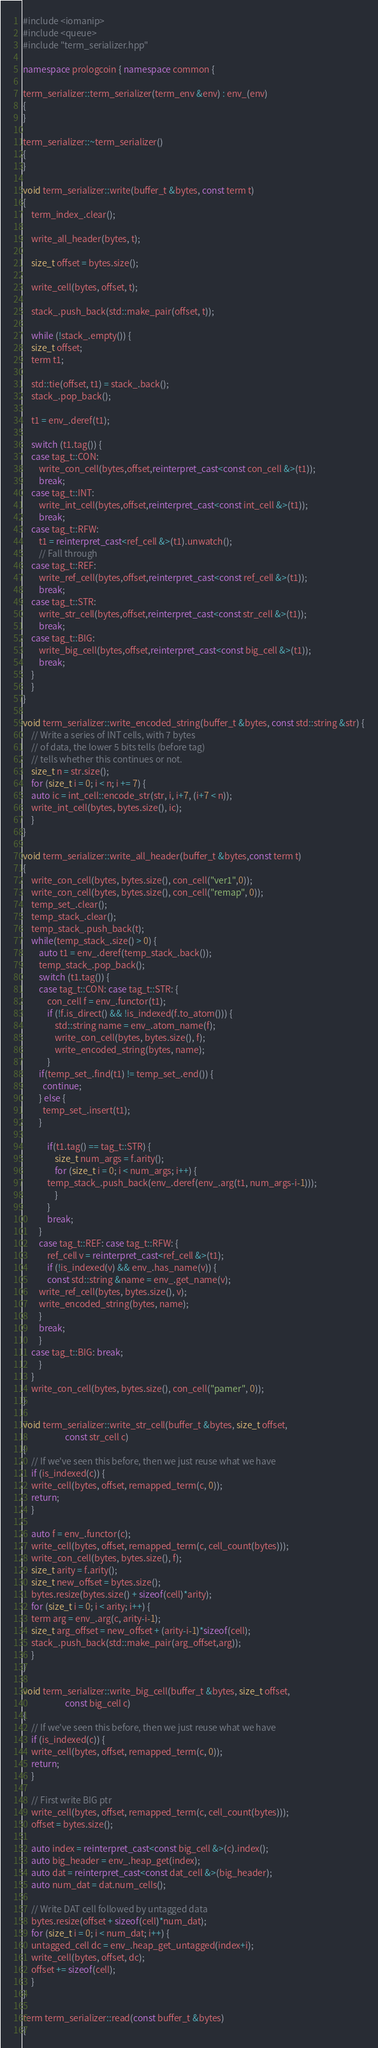Convert code to text. <code><loc_0><loc_0><loc_500><loc_500><_C++_>#include <iomanip>
#include <queue>
#include "term_serializer.hpp"

namespace prologcoin { namespace common {

term_serializer::term_serializer(term_env &env) : env_(env)
{
}

term_serializer::~term_serializer()
{
}

void term_serializer::write(buffer_t &bytes, const term t)
{
    term_index_.clear();
    
    write_all_header(bytes, t);

    size_t offset = bytes.size();

    write_cell(bytes, offset, t);

    stack_.push_back(std::make_pair(offset, t));

    while (!stack_.empty()) {
	size_t offset;
	term t1;

	std::tie(offset, t1) = stack_.back();
	stack_.pop_back();

	t1 = env_.deref(t1);

	switch (t1.tag()) {
	case tag_t::CON:
	    write_con_cell(bytes,offset,reinterpret_cast<const con_cell &>(t1));
	    break;
	case tag_t::INT:
	    write_int_cell(bytes,offset,reinterpret_cast<const int_cell &>(t1));
	    break;
	case tag_t::RFW:
	    t1 = reinterpret_cast<ref_cell &>(t1).unwatch();
	    // Fall through
	case tag_t::REF:
	    write_ref_cell(bytes,offset,reinterpret_cast<const ref_cell &>(t1));
	    break;
	case tag_t::STR:
	    write_str_cell(bytes,offset,reinterpret_cast<const str_cell &>(t1));
	    break;
	case tag_t::BIG:
	    write_big_cell(bytes,offset,reinterpret_cast<const big_cell &>(t1));
	    break;
	}
    }
}

void term_serializer::write_encoded_string(buffer_t &bytes, const std::string &str) {
    // Write a series of INT cells, with 7 bytes
    // of data, the lower 5 bits tells (before tag)
    // tells whether this continues or not.
    size_t n = str.size();
    for (size_t i = 0; i < n; i += 7) {
	auto ic = int_cell::encode_str(str, i, i+7, (i+7 < n));
	write_int_cell(bytes, bytes.size(), ic);
    }
}

void term_serializer::write_all_header(buffer_t &bytes,const term t)
{
    write_con_cell(bytes, bytes.size(), con_cell("ver1",0));
    write_con_cell(bytes, bytes.size(), con_cell("remap", 0));
    temp_set_.clear();
    temp_stack_.clear();
    temp_stack_.push_back(t);
    while(temp_stack_.size() > 0) {
        auto t1 = env_.deref(temp_stack_.back());
        temp_stack_.pop_back();
        switch (t1.tag()) {
        case tag_t::CON: case tag_t::STR: {
            con_cell f = env_.functor(t1);
            if (!f.is_direct() && !is_indexed(f.to_atom())) {
                std::string name = env_.atom_name(f);
                write_con_cell(bytes, bytes.size(), f);
                write_encoded_string(bytes, name);
            }
	    if(temp_set_.find(t1) != temp_set_.end()) {
	      continue;
	    } else {
	      temp_set_.insert(t1);
	    }

            if(t1.tag() == tag_t::STR) {
                size_t num_args = f.arity();
                for (size_t i = 0; i < num_args; i++) {
		    temp_stack_.push_back(env_.deref(env_.arg(t1, num_args-i-1)));
                }
            }
            break;
        }
        case tag_t::REF: case tag_t::RFW: { 
            ref_cell v = reinterpret_cast<ref_cell &>(t1);
            if (!is_indexed(v) && env_.has_name(v)) {
	        const std::string &name = env_.get_name(v);
		write_ref_cell(bytes, bytes.size(), v);
		write_encoded_string(bytes, name);
	    }
	    break;
	    }
	case tag_t::BIG: break;
        }
    }
    write_con_cell(bytes, bytes.size(), con_cell("pamer", 0));
}

void term_serializer::write_str_cell(buffer_t &bytes, size_t offset,
				     const str_cell c)
{
    // If we've seen this before, then we just reuse what we have
    if (is_indexed(c)) {
	write_cell(bytes, offset, remapped_term(c, 0));
	return;
    }

    auto f = env_.functor(c);
    write_cell(bytes, offset, remapped_term(c, cell_count(bytes)));
    write_con_cell(bytes, bytes.size(), f);
    size_t arity = f.arity();
    size_t new_offset = bytes.size();
    bytes.resize(bytes.size() + sizeof(cell)*arity);
    for (size_t i = 0; i < arity; i++) {
	term arg = env_.arg(c, arity-i-1);
	size_t arg_offset = new_offset + (arity-i-1)*sizeof(cell);
	stack_.push_back(std::make_pair(arg_offset,arg));
    }
}

void term_serializer::write_big_cell(buffer_t &bytes, size_t offset,
				     const big_cell c)
{
    // If we've seen this before, then we just reuse what we have
    if (is_indexed(c)) {
	write_cell(bytes, offset, remapped_term(c, 0));
	return;
    }

    // First write BIG ptr
    write_cell(bytes, offset, remapped_term(c, cell_count(bytes)));
    offset = bytes.size();

    auto index = reinterpret_cast<const big_cell &>(c).index();
    auto big_header = env_.heap_get(index);
    auto dat = reinterpret_cast<const dat_cell &>(big_header);
    auto num_dat = dat.num_cells();

    // Write DAT cell followed by untagged data
    bytes.resize(offset + sizeof(cell)*num_dat);
    for (size_t i = 0; i < num_dat; i++) {
	untagged_cell dc = env_.heap_get_untagged(index+i);
	write_cell(bytes, offset, dc);
	offset += sizeof(cell);
    }
}

term term_serializer::read(const buffer_t &bytes)
{</code> 